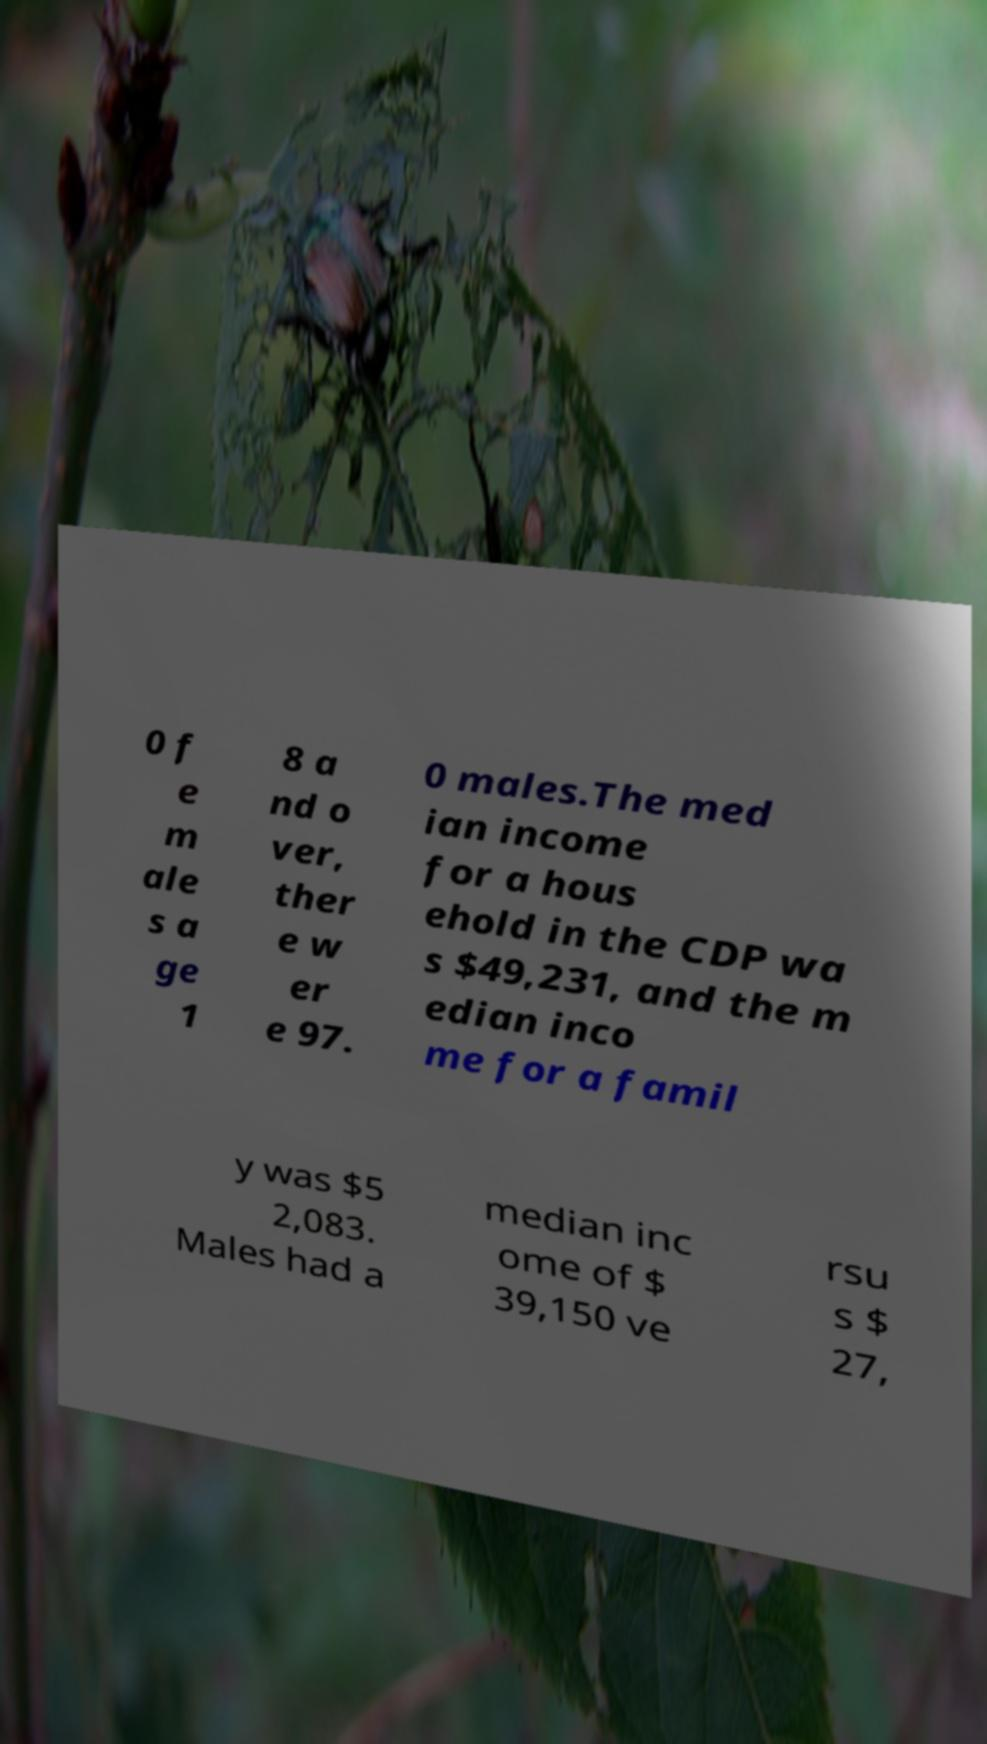Can you accurately transcribe the text from the provided image for me? 0 f e m ale s a ge 1 8 a nd o ver, ther e w er e 97. 0 males.The med ian income for a hous ehold in the CDP wa s $49,231, and the m edian inco me for a famil y was $5 2,083. Males had a median inc ome of $ 39,150 ve rsu s $ 27, 